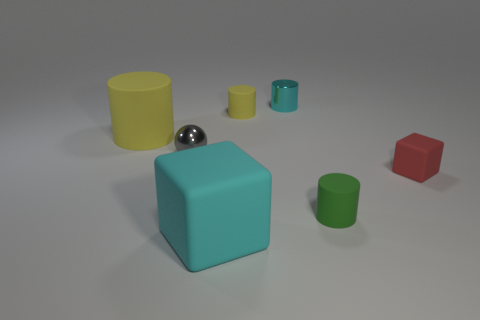Subtract 1 cylinders. How many cylinders are left? 3 Add 3 metal things. How many objects exist? 10 Subtract all cubes. How many objects are left? 5 Subtract all small gray rubber things. Subtract all cyan shiny cylinders. How many objects are left? 6 Add 1 yellow rubber cylinders. How many yellow rubber cylinders are left? 3 Add 7 big cubes. How many big cubes exist? 8 Subtract 0 yellow blocks. How many objects are left? 7 